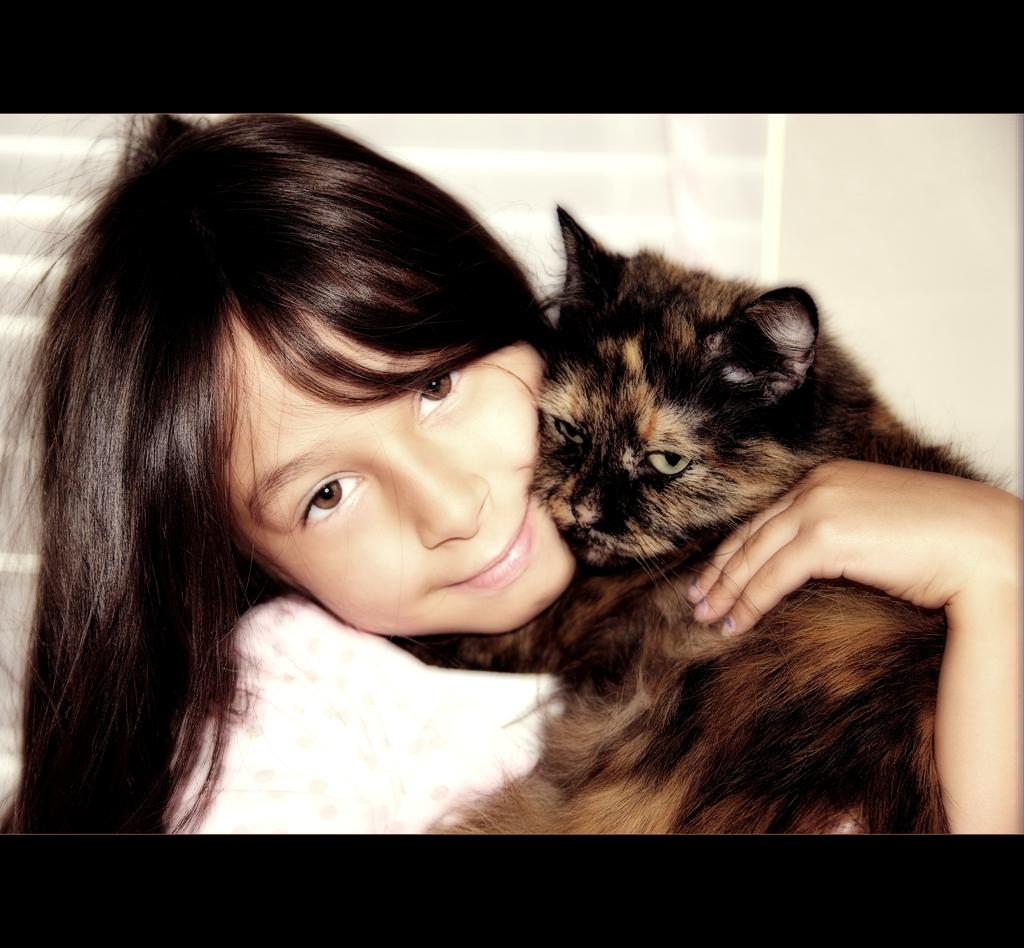What is the main subject of the image? The main subject of the image is a person riding a bicycle. What safety equipment is the person wearing? The person is wearing a helmet. What is the condition of the road in the image? The road is clear in the image. What type of wool can be seen on the building in the image? There is no building or wool present in the image; it features a person riding a bicycle on a clear road. 